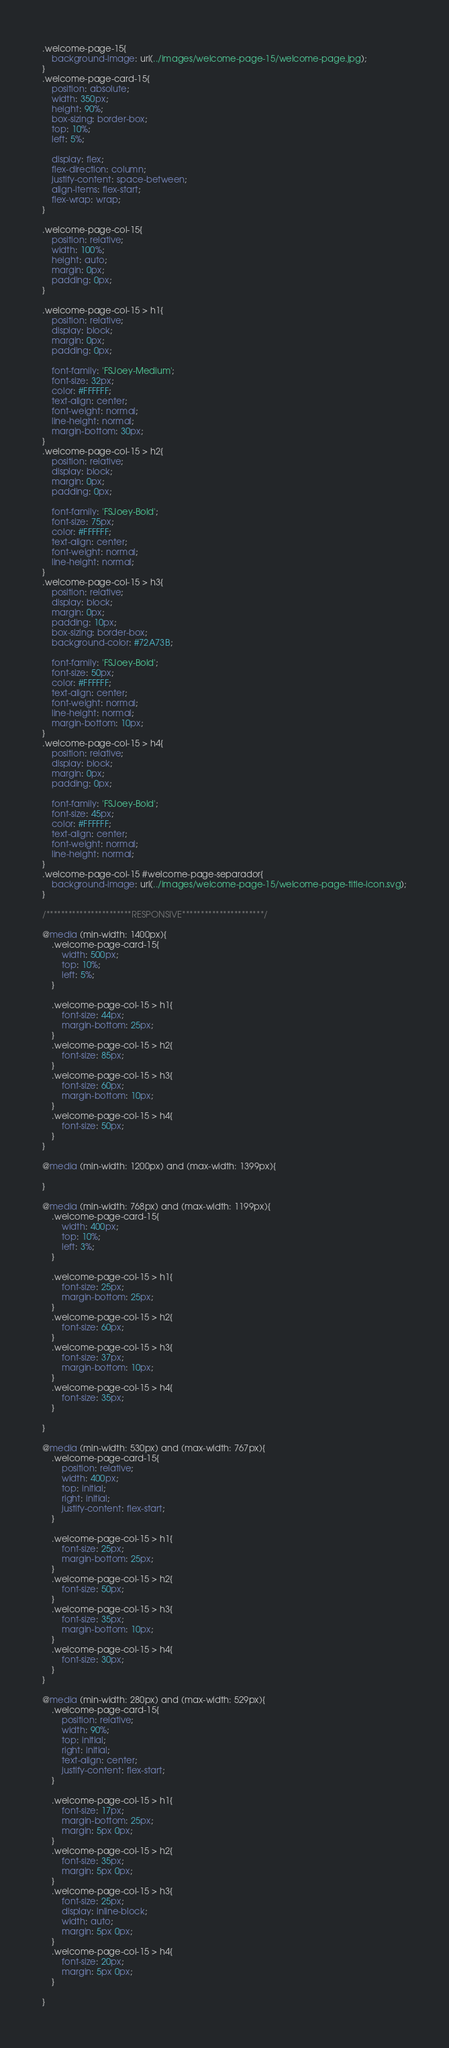Convert code to text. <code><loc_0><loc_0><loc_500><loc_500><_CSS_>.welcome-page-15{
    background-image: url(../images/welcome-page-15/welcome-page.jpg);
}
.welcome-page-card-15{
    position: absolute;
    width: 350px;
    height: 90%;
    box-sizing: border-box;
    top: 10%;
    left: 5%;

    display: flex;
    flex-direction: column;
    justify-content: space-between;
    align-items: flex-start;
    flex-wrap: wrap;
}

.welcome-page-col-15{
    position: relative;
    width: 100%;
    height: auto;
    margin: 0px;
    padding: 0px;
}

.welcome-page-col-15 > h1{
    position: relative;
    display: block;
    margin: 0px;
    padding: 0px;

    font-family: 'FSJoey-Medium';
    font-size: 32px;
    color: #FFFFFF;
    text-align: center;
    font-weight: normal;
    line-height: normal;
    margin-bottom: 30px;
}
.welcome-page-col-15 > h2{
    position: relative;
    display: block;
    margin: 0px;
    padding: 0px;

    font-family: 'FSJoey-Bold';
    font-size: 75px;
    color: #FFFFFF;
    text-align: center;
    font-weight: normal;
    line-height: normal;
}
.welcome-page-col-15 > h3{
    position: relative;
    display: block;
    margin: 0px;
    padding: 10px;
    box-sizing: border-box;
    background-color: #72A73B;

    font-family: 'FSJoey-Bold';
    font-size: 50px;
    color: #FFFFFF;
    text-align: center;
    font-weight: normal;
    line-height: normal;
    margin-bottom: 10px;
}
.welcome-page-col-15 > h4{
    position: relative;
    display: block;
    margin: 0px;
    padding: 0px;

    font-family: 'FSJoey-Bold';
    font-size: 45px;
    color: #FFFFFF;
    text-align: center;
    font-weight: normal;
    line-height: normal;
}
.welcome-page-col-15 #welcome-page-separador{
    background-image: url(../images/welcome-page-15/welcome-page-title-icon.svg);
}

/***********************RESPONSIVE**********************/

@media (min-width: 1400px){
    .welcome-page-card-15{
        width: 500px;
        top: 10%;
        left: 5%;
    }

    .welcome-page-col-15 > h1{
        font-size: 44px;
        margin-bottom: 25px;
    }
    .welcome-page-col-15 > h2{
        font-size: 85px;
    }
    .welcome-page-col-15 > h3{
        font-size: 60px;
        margin-bottom: 10px;
    }
    .welcome-page-col-15 > h4{
        font-size: 50px;
    }
}

@media (min-width: 1200px) and (max-width: 1399px){
    
}

@media (min-width: 768px) and (max-width: 1199px){
    .welcome-page-card-15{
        width: 400px;
        top: 10%;
        left: 3%;
    }

    .welcome-page-col-15 > h1{
        font-size: 25px;
        margin-bottom: 25px;
    }
    .welcome-page-col-15 > h2{
        font-size: 60px;
    }
    .welcome-page-col-15 > h3{
        font-size: 37px;
        margin-bottom: 10px;
    }
    .welcome-page-col-15 > h4{
        font-size: 35px;
    }
    
}

@media (min-width: 530px) and (max-width: 767px){
    .welcome-page-card-15{
        position: relative;
        width: 400px;
        top: initial;
        right: initial;
        justify-content: flex-start;
    }

    .welcome-page-col-15 > h1{
        font-size: 25px;
        margin-bottom: 25px;
    }
    .welcome-page-col-15 > h2{
        font-size: 50px;
    }
    .welcome-page-col-15 > h3{
        font-size: 35px;
        margin-bottom: 10px;
    }
    .welcome-page-col-15 > h4{
        font-size: 30px;
    }
}

@media (min-width: 280px) and (max-width: 529px){
    .welcome-page-card-15{
        position: relative;
        width: 90%;
        top: initial;
        right: initial;
        text-align: center;
        justify-content: flex-start;
    }

    .welcome-page-col-15 > h1{
        font-size: 17px;
        margin-bottom: 25px;
        margin: 5px 0px;
    }
    .welcome-page-col-15 > h2{
        font-size: 35px;
        margin: 5px 0px;
    }
    .welcome-page-col-15 > h3{
        font-size: 25px;
        display: inline-block;
        width: auto;
        margin: 5px 0px;
    }
    .welcome-page-col-15 > h4{
        font-size: 20px;
        margin: 5px 0px;
    }

}
</code> 